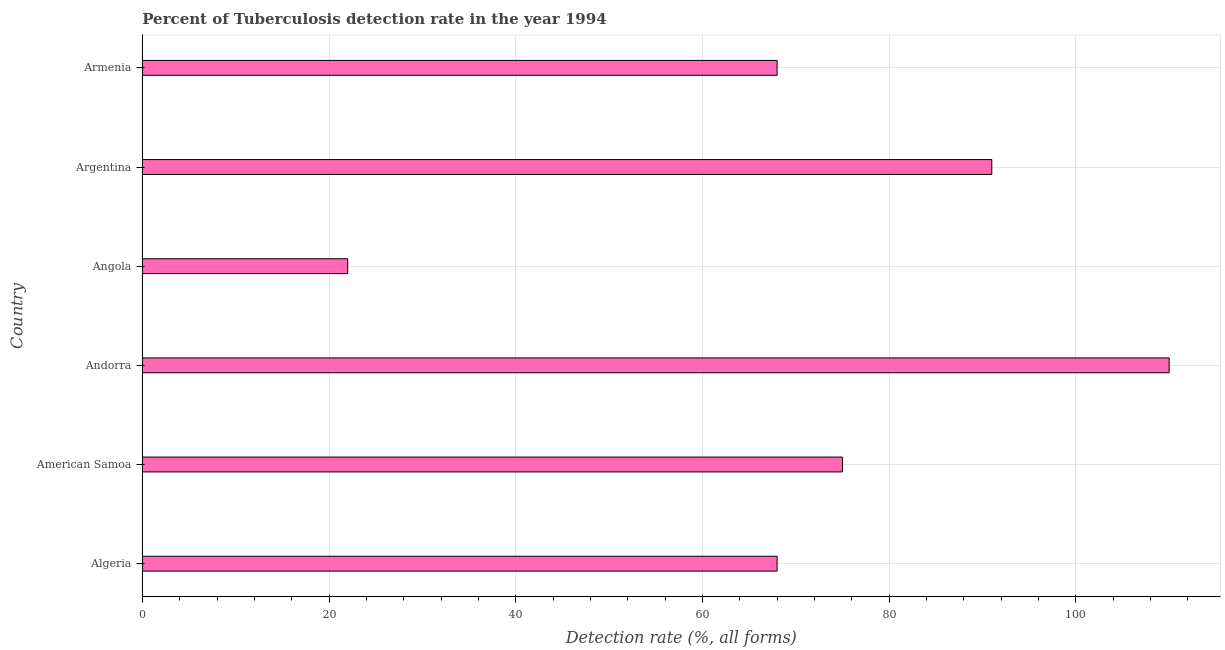What is the title of the graph?
Your answer should be very brief. Percent of Tuberculosis detection rate in the year 1994. What is the label or title of the X-axis?
Provide a short and direct response. Detection rate (%, all forms). What is the label or title of the Y-axis?
Offer a very short reply. Country. Across all countries, what is the maximum detection rate of tuberculosis?
Keep it short and to the point. 110. In which country was the detection rate of tuberculosis maximum?
Make the answer very short. Andorra. In which country was the detection rate of tuberculosis minimum?
Make the answer very short. Angola. What is the sum of the detection rate of tuberculosis?
Provide a short and direct response. 434. What is the difference between the detection rate of tuberculosis in Algeria and American Samoa?
Provide a short and direct response. -7. What is the average detection rate of tuberculosis per country?
Provide a short and direct response. 72.33. What is the median detection rate of tuberculosis?
Offer a very short reply. 71.5. In how many countries, is the detection rate of tuberculosis greater than 88 %?
Make the answer very short. 2. What is the ratio of the detection rate of tuberculosis in Angola to that in Argentina?
Offer a very short reply. 0.24. What is the difference between the highest and the second highest detection rate of tuberculosis?
Offer a very short reply. 19. Is the sum of the detection rate of tuberculosis in Algeria and Angola greater than the maximum detection rate of tuberculosis across all countries?
Your answer should be very brief. No. What is the difference between the highest and the lowest detection rate of tuberculosis?
Ensure brevity in your answer.  88. In how many countries, is the detection rate of tuberculosis greater than the average detection rate of tuberculosis taken over all countries?
Make the answer very short. 3. How many bars are there?
Your answer should be compact. 6. Are all the bars in the graph horizontal?
Offer a very short reply. Yes. How many countries are there in the graph?
Your answer should be compact. 6. What is the difference between two consecutive major ticks on the X-axis?
Ensure brevity in your answer.  20. Are the values on the major ticks of X-axis written in scientific E-notation?
Give a very brief answer. No. What is the Detection rate (%, all forms) in Algeria?
Offer a very short reply. 68. What is the Detection rate (%, all forms) of Andorra?
Ensure brevity in your answer.  110. What is the Detection rate (%, all forms) of Argentina?
Give a very brief answer. 91. What is the Detection rate (%, all forms) in Armenia?
Provide a succinct answer. 68. What is the difference between the Detection rate (%, all forms) in Algeria and Andorra?
Your answer should be very brief. -42. What is the difference between the Detection rate (%, all forms) in Algeria and Armenia?
Give a very brief answer. 0. What is the difference between the Detection rate (%, all forms) in American Samoa and Andorra?
Ensure brevity in your answer.  -35. What is the difference between the Detection rate (%, all forms) in American Samoa and Argentina?
Provide a short and direct response. -16. What is the difference between the Detection rate (%, all forms) in Andorra and Angola?
Your answer should be very brief. 88. What is the difference between the Detection rate (%, all forms) in Angola and Argentina?
Offer a very short reply. -69. What is the difference between the Detection rate (%, all forms) in Angola and Armenia?
Offer a terse response. -46. What is the ratio of the Detection rate (%, all forms) in Algeria to that in American Samoa?
Provide a short and direct response. 0.91. What is the ratio of the Detection rate (%, all forms) in Algeria to that in Andorra?
Your answer should be very brief. 0.62. What is the ratio of the Detection rate (%, all forms) in Algeria to that in Angola?
Your response must be concise. 3.09. What is the ratio of the Detection rate (%, all forms) in Algeria to that in Argentina?
Provide a succinct answer. 0.75. What is the ratio of the Detection rate (%, all forms) in Algeria to that in Armenia?
Make the answer very short. 1. What is the ratio of the Detection rate (%, all forms) in American Samoa to that in Andorra?
Your response must be concise. 0.68. What is the ratio of the Detection rate (%, all forms) in American Samoa to that in Angola?
Give a very brief answer. 3.41. What is the ratio of the Detection rate (%, all forms) in American Samoa to that in Argentina?
Your answer should be very brief. 0.82. What is the ratio of the Detection rate (%, all forms) in American Samoa to that in Armenia?
Keep it short and to the point. 1.1. What is the ratio of the Detection rate (%, all forms) in Andorra to that in Angola?
Ensure brevity in your answer.  5. What is the ratio of the Detection rate (%, all forms) in Andorra to that in Argentina?
Give a very brief answer. 1.21. What is the ratio of the Detection rate (%, all forms) in Andorra to that in Armenia?
Give a very brief answer. 1.62. What is the ratio of the Detection rate (%, all forms) in Angola to that in Argentina?
Keep it short and to the point. 0.24. What is the ratio of the Detection rate (%, all forms) in Angola to that in Armenia?
Your response must be concise. 0.32. What is the ratio of the Detection rate (%, all forms) in Argentina to that in Armenia?
Offer a very short reply. 1.34. 